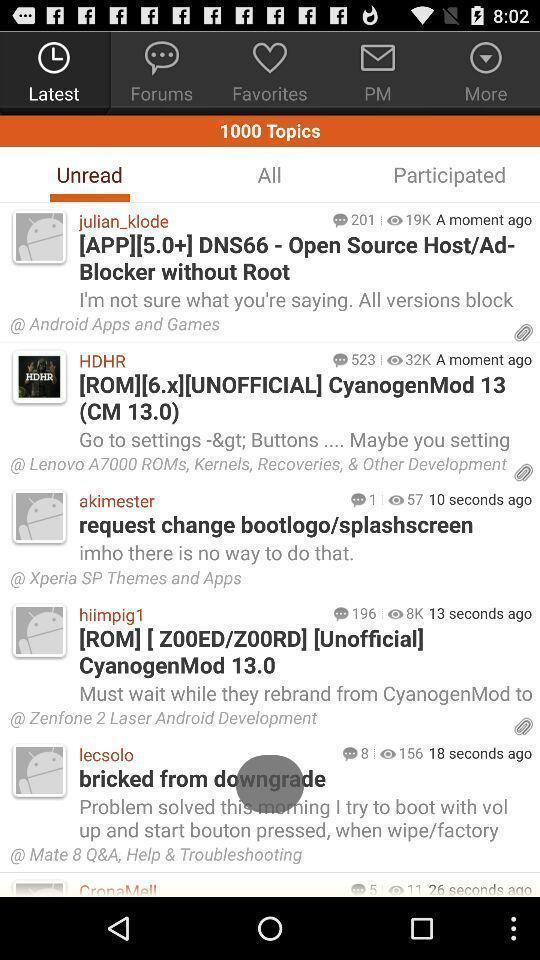Describe the visual elements of this screenshot. Page showing list of unread articles. 